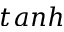<formula> <loc_0><loc_0><loc_500><loc_500>t a n h</formula> 